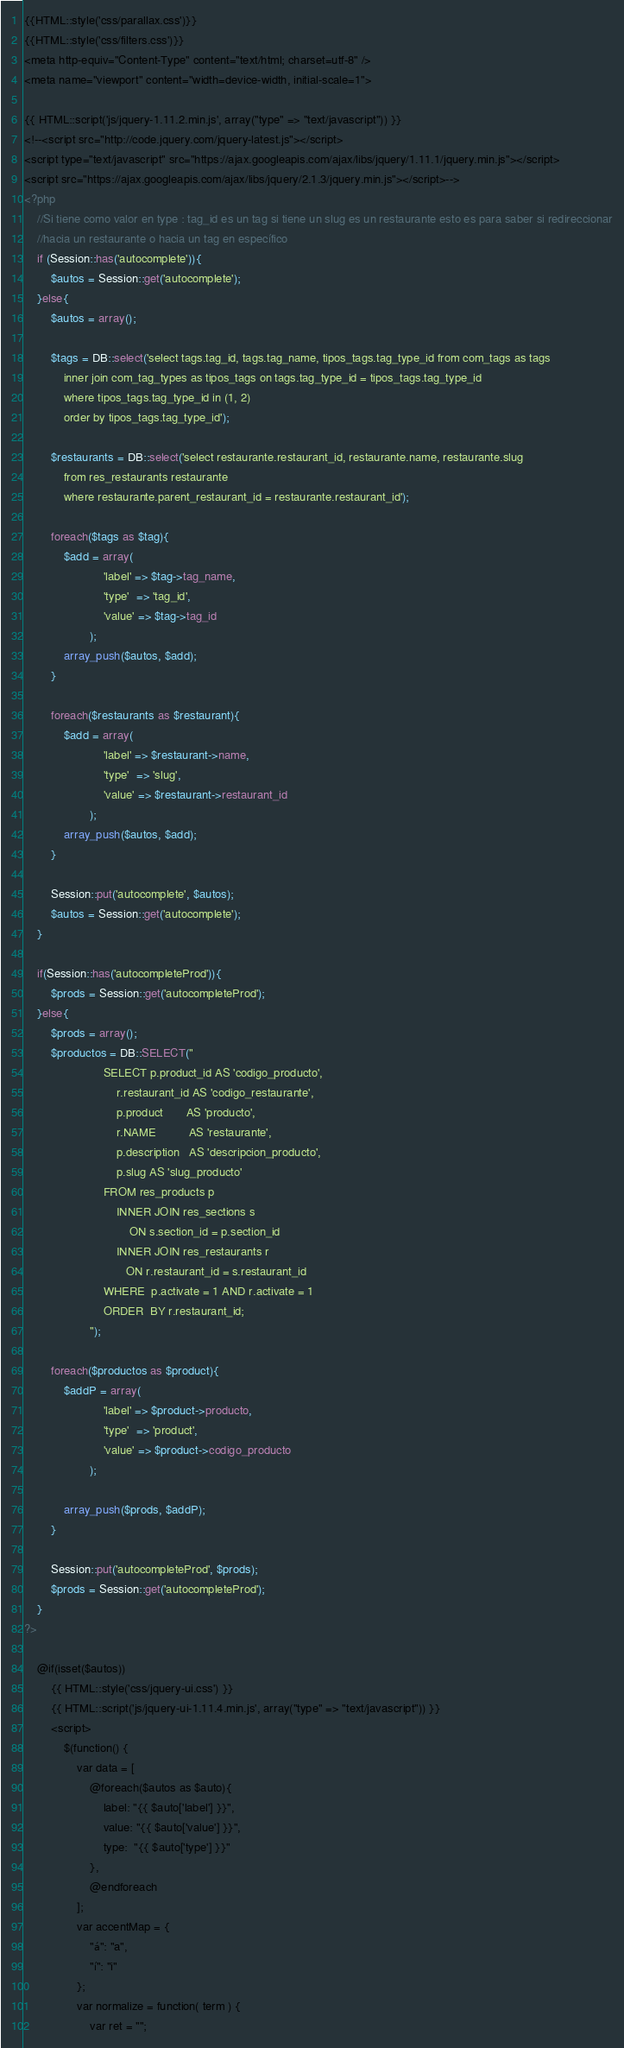Convert code to text. <code><loc_0><loc_0><loc_500><loc_500><_PHP_>{{HTML::style('css/parallax.css')}}
{{HTML::style('css/filters.css')}}
<meta http-equiv="Content-Type" content="text/html; charset=utf-8" />
<meta name="viewport" content="width=device-width, initial-scale=1">

{{ HTML::script('js/jquery-1.11.2.min.js', array("type" => "text/javascript")) }}
<!--<script src="http://code.jquery.com/jquery-latest.js"></script>
<script type="text/javascript" src="https://ajax.googleapis.com/ajax/libs/jquery/1.11.1/jquery.min.js"></script>
<script src="https://ajax.googleapis.com/ajax/libs/jquery/2.1.3/jquery.min.js"></script>-->
<?php
	//Si tiene como valor en type : tag_id es un tag si tiene un slug es un restaurante esto es para saber si redireccionar
	//hacia un restaurante o hacia un tag en específico
	if (Session::has('autocomplete')){
		$autos = Session::get('autocomplete');
	}else{
		$autos = array();		

		$tags = DB::select('select tags.tag_id, tags.tag_name, tipos_tags.tag_type_id from com_tags as tags
			inner join com_tag_types as tipos_tags on tags.tag_type_id = tipos_tags.tag_type_id
			where tipos_tags.tag_type_id in (1, 2)
			order by tipos_tags.tag_type_id');
		
		$restaurants = DB::select('select restaurante.restaurant_id, restaurante.name, restaurante.slug
			from res_restaurants restaurante
			where restaurante.parent_restaurant_id = restaurante.restaurant_id');		

		foreach($tags as $tag){
			$add = array(
						'label' => $tag->tag_name,
					 	'type'  => 'tag_id',
					 	'value' => $tag->tag_id
				 	);
			array_push($autos, $add);		
		}

		foreach($restaurants as $restaurant){
			$add = array(
						'label' => $restaurant->name, 
						'type'  => 'slug',
						'value' => $restaurant->restaurant_id
					);
			array_push($autos, $add);		
		}
		
		Session::put('autocomplete', $autos);		
		$autos = Session::get('autocomplete');
	}

	if(Session::has('autocompleteProd')){
		$prods = Session::get('autocompleteProd');
	}else{
		$prods = array();
		$productos = DB::SELECT("
						SELECT p.product_id AS 'codigo_producto',
						   	r.restaurant_id AS 'codigo_restaurante',
						   	p.product       AS 'producto',
						   	r.NAME          AS 'restaurante',   
						   	p.description   AS 'descripcion_producto',
						   	p.slug AS 'slug_producto'						       
						FROM res_products p
						   	INNER JOIN res_sections s
							   	ON s.section_id = p.section_id
						   	INNER JOIN res_restaurants r
							   ON r.restaurant_id = s.restaurant_id
						WHERE  p.activate = 1 AND r.activate = 1
						ORDER  BY r.restaurant_id;
					");
		
		foreach($productos as $product){
			$addP = array(
						'label' => $product->producto, 
					 	'type'  => 'product',
					 	'value' => $product->codigo_producto				 	
					);

			array_push($prods, $addP);		
		}
		
		Session::put('autocompleteProd', $prods);
		$prods = Session::get('autocompleteProd');
	}
?>

	@if(isset($autos))
		{{ HTML::style('css/jquery-ui.css') }}
		{{ HTML::script('js/jquery-ui-1.11.4.min.js', array("type" => "text/javascript")) }}
		<script>
			$(function() {
				var data = [
					@foreach($autos as $auto){ 
						label: "{{ $auto['label'] }}", 
						value: "{{ $auto['value'] }}", 
						type:  "{{ $auto['type'] }}"
					},
					@endforeach
				];
				var accentMap = {
					"á": "a",
					"í": "i"
				};
				var normalize = function( term ) {
					var ret = "";</code> 